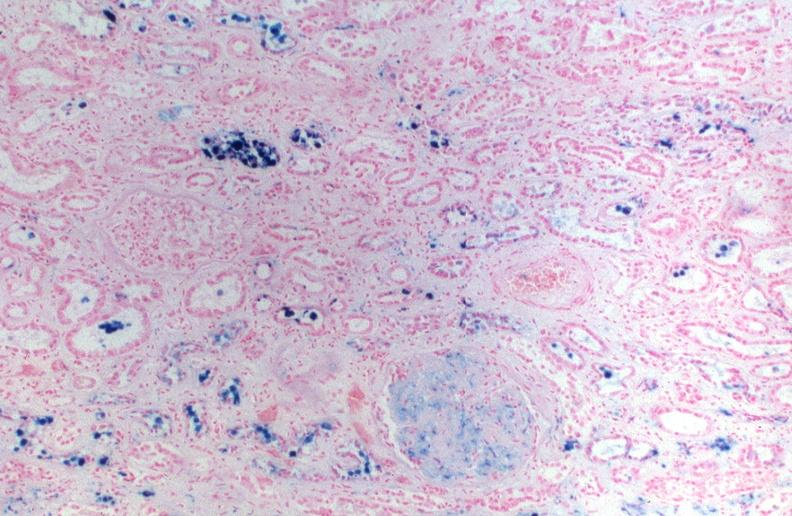does this image show kidney, hemochromatosis, prussian blue?
Answer the question using a single word or phrase. Yes 